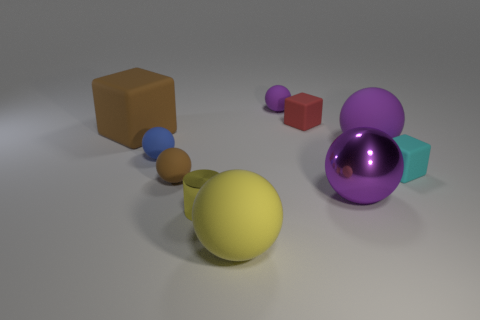What number of other objects are the same color as the cylinder?
Keep it short and to the point. 1. There is a large matte object in front of the blue object; does it have the same shape as the brown rubber object to the right of the blue ball?
Your answer should be compact. Yes. How many cylinders are either tiny yellow metal things or small red rubber objects?
Make the answer very short. 1. Is the number of small cylinders on the left side of the small blue object less than the number of small red rubber balls?
Keep it short and to the point. No. How many other things are made of the same material as the tiny brown thing?
Provide a short and direct response. 7. Do the cyan object and the blue sphere have the same size?
Keep it short and to the point. Yes. How many things are big rubber objects that are to the right of the cylinder or tiny rubber balls?
Offer a very short reply. 5. What is the material of the large purple thing that is in front of the small block on the right side of the tiny red object?
Provide a succinct answer. Metal. Are there any other small cyan objects of the same shape as the small shiny object?
Keep it short and to the point. No. There is a yellow metal cylinder; is it the same size as the purple matte sphere that is right of the tiny purple sphere?
Your answer should be very brief. No. 